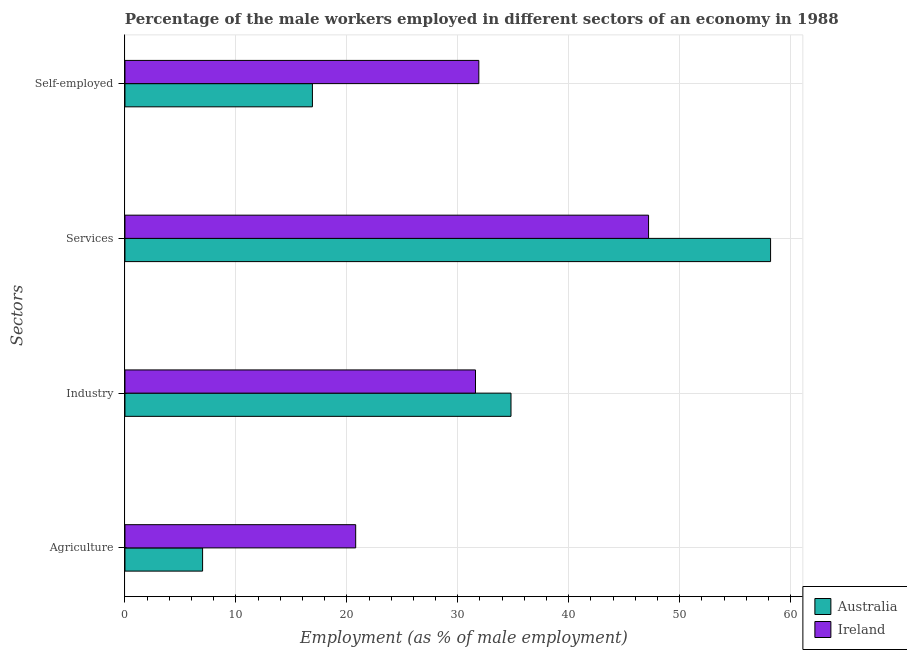How many different coloured bars are there?
Your answer should be very brief. 2. How many bars are there on the 3rd tick from the top?
Your answer should be very brief. 2. What is the label of the 2nd group of bars from the top?
Keep it short and to the point. Services. What is the percentage of male workers in services in Australia?
Offer a terse response. 58.2. Across all countries, what is the maximum percentage of self employed male workers?
Give a very brief answer. 31.9. Across all countries, what is the minimum percentage of male workers in services?
Provide a short and direct response. 47.2. In which country was the percentage of self employed male workers maximum?
Give a very brief answer. Ireland. In which country was the percentage of male workers in services minimum?
Offer a very short reply. Ireland. What is the total percentage of self employed male workers in the graph?
Your answer should be compact. 48.8. What is the difference between the percentage of male workers in agriculture in Australia and that in Ireland?
Offer a terse response. -13.8. What is the difference between the percentage of self employed male workers in Ireland and the percentage of male workers in agriculture in Australia?
Provide a short and direct response. 24.9. What is the average percentage of self employed male workers per country?
Provide a short and direct response. 24.4. What is the difference between the percentage of male workers in agriculture and percentage of male workers in services in Australia?
Your answer should be very brief. -51.2. In how many countries, is the percentage of male workers in services greater than 4 %?
Keep it short and to the point. 2. What is the ratio of the percentage of self employed male workers in Ireland to that in Australia?
Offer a terse response. 1.89. Is the percentage of male workers in industry in Ireland less than that in Australia?
Make the answer very short. Yes. What is the difference between the highest and the second highest percentage of male workers in industry?
Offer a very short reply. 3.2. What is the difference between the highest and the lowest percentage of male workers in agriculture?
Give a very brief answer. 13.8. In how many countries, is the percentage of self employed male workers greater than the average percentage of self employed male workers taken over all countries?
Offer a very short reply. 1. Is it the case that in every country, the sum of the percentage of male workers in services and percentage of male workers in agriculture is greater than the sum of percentage of self employed male workers and percentage of male workers in industry?
Make the answer very short. No. What does the 1st bar from the bottom in Industry represents?
Your answer should be compact. Australia. How many bars are there?
Give a very brief answer. 8. Are all the bars in the graph horizontal?
Your answer should be compact. Yes. Are the values on the major ticks of X-axis written in scientific E-notation?
Provide a succinct answer. No. How many legend labels are there?
Your response must be concise. 2. How are the legend labels stacked?
Your answer should be compact. Vertical. What is the title of the graph?
Your answer should be compact. Percentage of the male workers employed in different sectors of an economy in 1988. Does "Faeroe Islands" appear as one of the legend labels in the graph?
Provide a short and direct response. No. What is the label or title of the X-axis?
Your response must be concise. Employment (as % of male employment). What is the label or title of the Y-axis?
Make the answer very short. Sectors. What is the Employment (as % of male employment) of Ireland in Agriculture?
Ensure brevity in your answer.  20.8. What is the Employment (as % of male employment) of Australia in Industry?
Give a very brief answer. 34.8. What is the Employment (as % of male employment) in Ireland in Industry?
Keep it short and to the point. 31.6. What is the Employment (as % of male employment) of Australia in Services?
Offer a terse response. 58.2. What is the Employment (as % of male employment) of Ireland in Services?
Provide a succinct answer. 47.2. What is the Employment (as % of male employment) in Australia in Self-employed?
Give a very brief answer. 16.9. What is the Employment (as % of male employment) of Ireland in Self-employed?
Give a very brief answer. 31.9. Across all Sectors, what is the maximum Employment (as % of male employment) in Australia?
Ensure brevity in your answer.  58.2. Across all Sectors, what is the maximum Employment (as % of male employment) of Ireland?
Ensure brevity in your answer.  47.2. Across all Sectors, what is the minimum Employment (as % of male employment) of Australia?
Offer a very short reply. 7. Across all Sectors, what is the minimum Employment (as % of male employment) in Ireland?
Ensure brevity in your answer.  20.8. What is the total Employment (as % of male employment) in Australia in the graph?
Make the answer very short. 116.9. What is the total Employment (as % of male employment) in Ireland in the graph?
Provide a succinct answer. 131.5. What is the difference between the Employment (as % of male employment) of Australia in Agriculture and that in Industry?
Ensure brevity in your answer.  -27.8. What is the difference between the Employment (as % of male employment) in Australia in Agriculture and that in Services?
Offer a very short reply. -51.2. What is the difference between the Employment (as % of male employment) in Ireland in Agriculture and that in Services?
Provide a short and direct response. -26.4. What is the difference between the Employment (as % of male employment) in Australia in Industry and that in Services?
Offer a terse response. -23.4. What is the difference between the Employment (as % of male employment) of Ireland in Industry and that in Services?
Ensure brevity in your answer.  -15.6. What is the difference between the Employment (as % of male employment) in Australia in Industry and that in Self-employed?
Provide a succinct answer. 17.9. What is the difference between the Employment (as % of male employment) of Ireland in Industry and that in Self-employed?
Your answer should be compact. -0.3. What is the difference between the Employment (as % of male employment) in Australia in Services and that in Self-employed?
Your response must be concise. 41.3. What is the difference between the Employment (as % of male employment) in Ireland in Services and that in Self-employed?
Make the answer very short. 15.3. What is the difference between the Employment (as % of male employment) in Australia in Agriculture and the Employment (as % of male employment) in Ireland in Industry?
Your answer should be very brief. -24.6. What is the difference between the Employment (as % of male employment) in Australia in Agriculture and the Employment (as % of male employment) in Ireland in Services?
Provide a succinct answer. -40.2. What is the difference between the Employment (as % of male employment) of Australia in Agriculture and the Employment (as % of male employment) of Ireland in Self-employed?
Ensure brevity in your answer.  -24.9. What is the difference between the Employment (as % of male employment) in Australia in Services and the Employment (as % of male employment) in Ireland in Self-employed?
Your response must be concise. 26.3. What is the average Employment (as % of male employment) in Australia per Sectors?
Keep it short and to the point. 29.23. What is the average Employment (as % of male employment) of Ireland per Sectors?
Make the answer very short. 32.88. What is the difference between the Employment (as % of male employment) in Australia and Employment (as % of male employment) in Ireland in Agriculture?
Make the answer very short. -13.8. What is the difference between the Employment (as % of male employment) of Australia and Employment (as % of male employment) of Ireland in Industry?
Your response must be concise. 3.2. What is the ratio of the Employment (as % of male employment) of Australia in Agriculture to that in Industry?
Offer a very short reply. 0.2. What is the ratio of the Employment (as % of male employment) of Ireland in Agriculture to that in Industry?
Keep it short and to the point. 0.66. What is the ratio of the Employment (as % of male employment) in Australia in Agriculture to that in Services?
Your answer should be compact. 0.12. What is the ratio of the Employment (as % of male employment) in Ireland in Agriculture to that in Services?
Provide a succinct answer. 0.44. What is the ratio of the Employment (as % of male employment) of Australia in Agriculture to that in Self-employed?
Provide a succinct answer. 0.41. What is the ratio of the Employment (as % of male employment) in Ireland in Agriculture to that in Self-employed?
Give a very brief answer. 0.65. What is the ratio of the Employment (as % of male employment) of Australia in Industry to that in Services?
Your response must be concise. 0.6. What is the ratio of the Employment (as % of male employment) in Ireland in Industry to that in Services?
Offer a very short reply. 0.67. What is the ratio of the Employment (as % of male employment) in Australia in Industry to that in Self-employed?
Make the answer very short. 2.06. What is the ratio of the Employment (as % of male employment) in Ireland in Industry to that in Self-employed?
Your response must be concise. 0.99. What is the ratio of the Employment (as % of male employment) of Australia in Services to that in Self-employed?
Offer a very short reply. 3.44. What is the ratio of the Employment (as % of male employment) in Ireland in Services to that in Self-employed?
Offer a terse response. 1.48. What is the difference between the highest and the second highest Employment (as % of male employment) in Australia?
Your answer should be very brief. 23.4. What is the difference between the highest and the second highest Employment (as % of male employment) of Ireland?
Make the answer very short. 15.3. What is the difference between the highest and the lowest Employment (as % of male employment) in Australia?
Make the answer very short. 51.2. What is the difference between the highest and the lowest Employment (as % of male employment) of Ireland?
Your response must be concise. 26.4. 